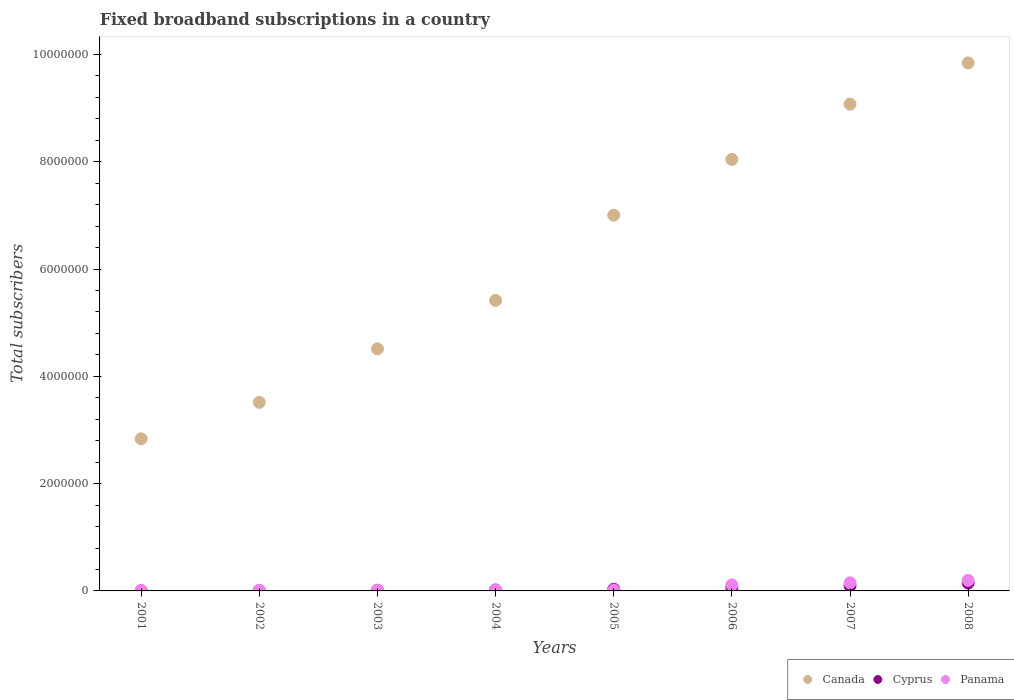How many different coloured dotlines are there?
Make the answer very short. 3. What is the number of broadband subscriptions in Canada in 2001?
Make the answer very short. 2.84e+06. Across all years, what is the maximum number of broadband subscriptions in Canada?
Your answer should be very brief. 9.84e+06. Across all years, what is the minimum number of broadband subscriptions in Panama?
Provide a succinct answer. 7771. In which year was the number of broadband subscriptions in Cyprus maximum?
Provide a short and direct response. 2008. In which year was the number of broadband subscriptions in Panama minimum?
Make the answer very short. 2001. What is the total number of broadband subscriptions in Cyprus in the graph?
Offer a terse response. 3.75e+05. What is the difference between the number of broadband subscriptions in Panama in 2001 and that in 2007?
Provide a short and direct response. -1.43e+05. What is the difference between the number of broadband subscriptions in Cyprus in 2005 and the number of broadband subscriptions in Panama in 2008?
Your answer should be very brief. -1.64e+05. What is the average number of broadband subscriptions in Canada per year?
Provide a succinct answer. 6.28e+06. In the year 2003, what is the difference between the number of broadband subscriptions in Panama and number of broadband subscriptions in Cyprus?
Provide a succinct answer. 5006. What is the ratio of the number of broadband subscriptions in Canada in 2005 to that in 2008?
Give a very brief answer. 0.71. What is the difference between the highest and the second highest number of broadband subscriptions in Canada?
Your response must be concise. 7.67e+05. What is the difference between the highest and the lowest number of broadband subscriptions in Cyprus?
Your answer should be compact. 1.45e+05. Is the sum of the number of broadband subscriptions in Cyprus in 2003 and 2004 greater than the maximum number of broadband subscriptions in Canada across all years?
Your response must be concise. No. How many years are there in the graph?
Your response must be concise. 8. Are the values on the major ticks of Y-axis written in scientific E-notation?
Your answer should be very brief. No. Does the graph contain any zero values?
Your answer should be very brief. No. Does the graph contain grids?
Your response must be concise. No. How many legend labels are there?
Offer a terse response. 3. How are the legend labels stacked?
Offer a terse response. Horizontal. What is the title of the graph?
Your answer should be very brief. Fixed broadband subscriptions in a country. Does "Samoa" appear as one of the legend labels in the graph?
Your answer should be compact. No. What is the label or title of the Y-axis?
Ensure brevity in your answer.  Total subscribers. What is the Total subscribers in Canada in 2001?
Provide a short and direct response. 2.84e+06. What is the Total subscribers in Cyprus in 2001?
Keep it short and to the point. 2500. What is the Total subscribers of Panama in 2001?
Ensure brevity in your answer.  7771. What is the Total subscribers of Canada in 2002?
Your response must be concise. 3.52e+06. What is the Total subscribers of Cyprus in 2002?
Your answer should be compact. 5879. What is the Total subscribers of Panama in 2002?
Your response must be concise. 1.22e+04. What is the Total subscribers in Canada in 2003?
Your answer should be very brief. 4.51e+06. What is the Total subscribers in Cyprus in 2003?
Offer a very short reply. 1.00e+04. What is the Total subscribers in Panama in 2003?
Provide a short and direct response. 1.50e+04. What is the Total subscribers of Canada in 2004?
Your response must be concise. 5.42e+06. What is the Total subscribers of Cyprus in 2004?
Your answer should be compact. 1.71e+04. What is the Total subscribers of Panama in 2004?
Provide a succinct answer. 1.67e+04. What is the Total subscribers in Canada in 2005?
Your answer should be very brief. 7.00e+06. What is the Total subscribers of Cyprus in 2005?
Offer a very short reply. 3.19e+04. What is the Total subscribers of Panama in 2005?
Ensure brevity in your answer.  1.76e+04. What is the Total subscribers in Canada in 2006?
Your answer should be very brief. 8.04e+06. What is the Total subscribers in Cyprus in 2006?
Provide a succinct answer. 6.31e+04. What is the Total subscribers in Panama in 2006?
Give a very brief answer. 1.13e+05. What is the Total subscribers of Canada in 2007?
Your response must be concise. 9.08e+06. What is the Total subscribers of Cyprus in 2007?
Make the answer very short. 9.76e+04. What is the Total subscribers of Panama in 2007?
Offer a terse response. 1.50e+05. What is the Total subscribers of Canada in 2008?
Your answer should be compact. 9.84e+06. What is the Total subscribers of Cyprus in 2008?
Offer a terse response. 1.47e+05. What is the Total subscribers of Panama in 2008?
Your answer should be very brief. 1.96e+05. Across all years, what is the maximum Total subscribers in Canada?
Provide a short and direct response. 9.84e+06. Across all years, what is the maximum Total subscribers in Cyprus?
Keep it short and to the point. 1.47e+05. Across all years, what is the maximum Total subscribers in Panama?
Ensure brevity in your answer.  1.96e+05. Across all years, what is the minimum Total subscribers in Canada?
Provide a short and direct response. 2.84e+06. Across all years, what is the minimum Total subscribers of Cyprus?
Provide a short and direct response. 2500. Across all years, what is the minimum Total subscribers in Panama?
Keep it short and to the point. 7771. What is the total Total subscribers in Canada in the graph?
Offer a terse response. 5.02e+07. What is the total Total subscribers in Cyprus in the graph?
Your response must be concise. 3.75e+05. What is the total Total subscribers of Panama in the graph?
Your response must be concise. 5.29e+05. What is the difference between the Total subscribers in Canada in 2001 and that in 2002?
Keep it short and to the point. -6.79e+05. What is the difference between the Total subscribers of Cyprus in 2001 and that in 2002?
Make the answer very short. -3379. What is the difference between the Total subscribers of Panama in 2001 and that in 2002?
Your answer should be very brief. -4464. What is the difference between the Total subscribers in Canada in 2001 and that in 2003?
Your answer should be compact. -1.68e+06. What is the difference between the Total subscribers in Cyprus in 2001 and that in 2003?
Your response must be concise. -7533. What is the difference between the Total subscribers of Panama in 2001 and that in 2003?
Make the answer very short. -7268. What is the difference between the Total subscribers in Canada in 2001 and that in 2004?
Keep it short and to the point. -2.58e+06. What is the difference between the Total subscribers of Cyprus in 2001 and that in 2004?
Provide a succinct answer. -1.46e+04. What is the difference between the Total subscribers in Panama in 2001 and that in 2004?
Keep it short and to the point. -8975. What is the difference between the Total subscribers of Canada in 2001 and that in 2005?
Make the answer very short. -4.17e+06. What is the difference between the Total subscribers of Cyprus in 2001 and that in 2005?
Provide a short and direct response. -2.94e+04. What is the difference between the Total subscribers in Panama in 2001 and that in 2005?
Provide a succinct answer. -9796. What is the difference between the Total subscribers in Canada in 2001 and that in 2006?
Provide a succinct answer. -5.21e+06. What is the difference between the Total subscribers of Cyprus in 2001 and that in 2006?
Offer a terse response. -6.06e+04. What is the difference between the Total subscribers of Panama in 2001 and that in 2006?
Keep it short and to the point. -1.05e+05. What is the difference between the Total subscribers in Canada in 2001 and that in 2007?
Give a very brief answer. -6.24e+06. What is the difference between the Total subscribers of Cyprus in 2001 and that in 2007?
Keep it short and to the point. -9.51e+04. What is the difference between the Total subscribers in Panama in 2001 and that in 2007?
Offer a very short reply. -1.43e+05. What is the difference between the Total subscribers in Canada in 2001 and that in 2008?
Your response must be concise. -7.01e+06. What is the difference between the Total subscribers of Cyprus in 2001 and that in 2008?
Make the answer very short. -1.45e+05. What is the difference between the Total subscribers in Panama in 2001 and that in 2008?
Provide a short and direct response. -1.88e+05. What is the difference between the Total subscribers of Canada in 2002 and that in 2003?
Ensure brevity in your answer.  -9.98e+05. What is the difference between the Total subscribers of Cyprus in 2002 and that in 2003?
Offer a very short reply. -4154. What is the difference between the Total subscribers in Panama in 2002 and that in 2003?
Offer a very short reply. -2804. What is the difference between the Total subscribers of Canada in 2002 and that in 2004?
Your answer should be very brief. -1.90e+06. What is the difference between the Total subscribers in Cyprus in 2002 and that in 2004?
Keep it short and to the point. -1.12e+04. What is the difference between the Total subscribers of Panama in 2002 and that in 2004?
Offer a terse response. -4511. What is the difference between the Total subscribers of Canada in 2002 and that in 2005?
Provide a succinct answer. -3.49e+06. What is the difference between the Total subscribers in Cyprus in 2002 and that in 2005?
Provide a short and direct response. -2.60e+04. What is the difference between the Total subscribers in Panama in 2002 and that in 2005?
Give a very brief answer. -5332. What is the difference between the Total subscribers of Canada in 2002 and that in 2006?
Your answer should be very brief. -4.53e+06. What is the difference between the Total subscribers in Cyprus in 2002 and that in 2006?
Offer a very short reply. -5.72e+04. What is the difference between the Total subscribers in Panama in 2002 and that in 2006?
Provide a short and direct response. -1.01e+05. What is the difference between the Total subscribers in Canada in 2002 and that in 2007?
Make the answer very short. -5.56e+06. What is the difference between the Total subscribers of Cyprus in 2002 and that in 2007?
Your response must be concise. -9.17e+04. What is the difference between the Total subscribers in Panama in 2002 and that in 2007?
Offer a very short reply. -1.38e+05. What is the difference between the Total subscribers in Canada in 2002 and that in 2008?
Offer a very short reply. -6.33e+06. What is the difference between the Total subscribers of Cyprus in 2002 and that in 2008?
Your answer should be very brief. -1.41e+05. What is the difference between the Total subscribers of Panama in 2002 and that in 2008?
Ensure brevity in your answer.  -1.84e+05. What is the difference between the Total subscribers of Canada in 2003 and that in 2004?
Keep it short and to the point. -9.03e+05. What is the difference between the Total subscribers in Cyprus in 2003 and that in 2004?
Your answer should be compact. -7037. What is the difference between the Total subscribers in Panama in 2003 and that in 2004?
Your response must be concise. -1707. What is the difference between the Total subscribers in Canada in 2003 and that in 2005?
Ensure brevity in your answer.  -2.49e+06. What is the difference between the Total subscribers of Cyprus in 2003 and that in 2005?
Your answer should be very brief. -2.18e+04. What is the difference between the Total subscribers of Panama in 2003 and that in 2005?
Your answer should be compact. -2528. What is the difference between the Total subscribers of Canada in 2003 and that in 2006?
Provide a succinct answer. -3.53e+06. What is the difference between the Total subscribers in Cyprus in 2003 and that in 2006?
Give a very brief answer. -5.31e+04. What is the difference between the Total subscribers in Panama in 2003 and that in 2006?
Ensure brevity in your answer.  -9.77e+04. What is the difference between the Total subscribers of Canada in 2003 and that in 2007?
Your response must be concise. -4.56e+06. What is the difference between the Total subscribers of Cyprus in 2003 and that in 2007?
Provide a succinct answer. -8.76e+04. What is the difference between the Total subscribers of Panama in 2003 and that in 2007?
Your answer should be compact. -1.35e+05. What is the difference between the Total subscribers of Canada in 2003 and that in 2008?
Keep it short and to the point. -5.33e+06. What is the difference between the Total subscribers in Cyprus in 2003 and that in 2008?
Make the answer very short. -1.37e+05. What is the difference between the Total subscribers in Panama in 2003 and that in 2008?
Your response must be concise. -1.81e+05. What is the difference between the Total subscribers in Canada in 2004 and that in 2005?
Ensure brevity in your answer.  -1.59e+06. What is the difference between the Total subscribers of Cyprus in 2004 and that in 2005?
Provide a succinct answer. -1.48e+04. What is the difference between the Total subscribers of Panama in 2004 and that in 2005?
Provide a succinct answer. -821. What is the difference between the Total subscribers in Canada in 2004 and that in 2006?
Give a very brief answer. -2.63e+06. What is the difference between the Total subscribers of Cyprus in 2004 and that in 2006?
Your response must be concise. -4.60e+04. What is the difference between the Total subscribers in Panama in 2004 and that in 2006?
Ensure brevity in your answer.  -9.60e+04. What is the difference between the Total subscribers of Canada in 2004 and that in 2007?
Your answer should be very brief. -3.66e+06. What is the difference between the Total subscribers of Cyprus in 2004 and that in 2007?
Provide a short and direct response. -8.05e+04. What is the difference between the Total subscribers of Panama in 2004 and that in 2007?
Give a very brief answer. -1.34e+05. What is the difference between the Total subscribers of Canada in 2004 and that in 2008?
Your answer should be compact. -4.43e+06. What is the difference between the Total subscribers of Cyprus in 2004 and that in 2008?
Make the answer very short. -1.30e+05. What is the difference between the Total subscribers of Panama in 2004 and that in 2008?
Your response must be concise. -1.79e+05. What is the difference between the Total subscribers of Canada in 2005 and that in 2006?
Make the answer very short. -1.04e+06. What is the difference between the Total subscribers in Cyprus in 2005 and that in 2006?
Provide a short and direct response. -3.12e+04. What is the difference between the Total subscribers of Panama in 2005 and that in 2006?
Offer a very short reply. -9.52e+04. What is the difference between the Total subscribers of Canada in 2005 and that in 2007?
Provide a short and direct response. -2.07e+06. What is the difference between the Total subscribers of Cyprus in 2005 and that in 2007?
Offer a very short reply. -6.58e+04. What is the difference between the Total subscribers in Panama in 2005 and that in 2007?
Ensure brevity in your answer.  -1.33e+05. What is the difference between the Total subscribers in Canada in 2005 and that in 2008?
Your answer should be compact. -2.84e+06. What is the difference between the Total subscribers in Cyprus in 2005 and that in 2008?
Provide a succinct answer. -1.15e+05. What is the difference between the Total subscribers of Panama in 2005 and that in 2008?
Give a very brief answer. -1.79e+05. What is the difference between the Total subscribers of Canada in 2006 and that in 2007?
Ensure brevity in your answer.  -1.03e+06. What is the difference between the Total subscribers in Cyprus in 2006 and that in 2007?
Provide a short and direct response. -3.45e+04. What is the difference between the Total subscribers in Panama in 2006 and that in 2007?
Keep it short and to the point. -3.75e+04. What is the difference between the Total subscribers in Canada in 2006 and that in 2008?
Keep it short and to the point. -1.80e+06. What is the difference between the Total subscribers of Cyprus in 2006 and that in 2008?
Keep it short and to the point. -8.42e+04. What is the difference between the Total subscribers in Panama in 2006 and that in 2008?
Give a very brief answer. -8.35e+04. What is the difference between the Total subscribers in Canada in 2007 and that in 2008?
Provide a succinct answer. -7.67e+05. What is the difference between the Total subscribers of Cyprus in 2007 and that in 2008?
Ensure brevity in your answer.  -4.97e+04. What is the difference between the Total subscribers of Panama in 2007 and that in 2008?
Give a very brief answer. -4.59e+04. What is the difference between the Total subscribers of Canada in 2001 and the Total subscribers of Cyprus in 2002?
Provide a short and direct response. 2.83e+06. What is the difference between the Total subscribers of Canada in 2001 and the Total subscribers of Panama in 2002?
Give a very brief answer. 2.82e+06. What is the difference between the Total subscribers in Cyprus in 2001 and the Total subscribers in Panama in 2002?
Provide a short and direct response. -9735. What is the difference between the Total subscribers of Canada in 2001 and the Total subscribers of Cyprus in 2003?
Offer a terse response. 2.83e+06. What is the difference between the Total subscribers in Canada in 2001 and the Total subscribers in Panama in 2003?
Offer a terse response. 2.82e+06. What is the difference between the Total subscribers in Cyprus in 2001 and the Total subscribers in Panama in 2003?
Keep it short and to the point. -1.25e+04. What is the difference between the Total subscribers of Canada in 2001 and the Total subscribers of Cyprus in 2004?
Ensure brevity in your answer.  2.82e+06. What is the difference between the Total subscribers in Canada in 2001 and the Total subscribers in Panama in 2004?
Ensure brevity in your answer.  2.82e+06. What is the difference between the Total subscribers in Cyprus in 2001 and the Total subscribers in Panama in 2004?
Provide a short and direct response. -1.42e+04. What is the difference between the Total subscribers of Canada in 2001 and the Total subscribers of Cyprus in 2005?
Offer a very short reply. 2.80e+06. What is the difference between the Total subscribers of Canada in 2001 and the Total subscribers of Panama in 2005?
Provide a succinct answer. 2.82e+06. What is the difference between the Total subscribers of Cyprus in 2001 and the Total subscribers of Panama in 2005?
Keep it short and to the point. -1.51e+04. What is the difference between the Total subscribers of Canada in 2001 and the Total subscribers of Cyprus in 2006?
Your answer should be compact. 2.77e+06. What is the difference between the Total subscribers in Canada in 2001 and the Total subscribers in Panama in 2006?
Ensure brevity in your answer.  2.72e+06. What is the difference between the Total subscribers of Cyprus in 2001 and the Total subscribers of Panama in 2006?
Your answer should be compact. -1.10e+05. What is the difference between the Total subscribers of Canada in 2001 and the Total subscribers of Cyprus in 2007?
Your response must be concise. 2.74e+06. What is the difference between the Total subscribers of Canada in 2001 and the Total subscribers of Panama in 2007?
Give a very brief answer. 2.69e+06. What is the difference between the Total subscribers of Cyprus in 2001 and the Total subscribers of Panama in 2007?
Offer a very short reply. -1.48e+05. What is the difference between the Total subscribers in Canada in 2001 and the Total subscribers in Cyprus in 2008?
Your answer should be very brief. 2.69e+06. What is the difference between the Total subscribers of Canada in 2001 and the Total subscribers of Panama in 2008?
Your response must be concise. 2.64e+06. What is the difference between the Total subscribers of Cyprus in 2001 and the Total subscribers of Panama in 2008?
Provide a short and direct response. -1.94e+05. What is the difference between the Total subscribers in Canada in 2002 and the Total subscribers in Cyprus in 2003?
Your answer should be compact. 3.50e+06. What is the difference between the Total subscribers of Canada in 2002 and the Total subscribers of Panama in 2003?
Offer a very short reply. 3.50e+06. What is the difference between the Total subscribers of Cyprus in 2002 and the Total subscribers of Panama in 2003?
Your answer should be compact. -9160. What is the difference between the Total subscribers of Canada in 2002 and the Total subscribers of Cyprus in 2004?
Provide a succinct answer. 3.50e+06. What is the difference between the Total subscribers in Canada in 2002 and the Total subscribers in Panama in 2004?
Your answer should be compact. 3.50e+06. What is the difference between the Total subscribers in Cyprus in 2002 and the Total subscribers in Panama in 2004?
Provide a short and direct response. -1.09e+04. What is the difference between the Total subscribers in Canada in 2002 and the Total subscribers in Cyprus in 2005?
Make the answer very short. 3.48e+06. What is the difference between the Total subscribers of Canada in 2002 and the Total subscribers of Panama in 2005?
Provide a short and direct response. 3.50e+06. What is the difference between the Total subscribers in Cyprus in 2002 and the Total subscribers in Panama in 2005?
Give a very brief answer. -1.17e+04. What is the difference between the Total subscribers in Canada in 2002 and the Total subscribers in Cyprus in 2006?
Provide a succinct answer. 3.45e+06. What is the difference between the Total subscribers of Canada in 2002 and the Total subscribers of Panama in 2006?
Your answer should be very brief. 3.40e+06. What is the difference between the Total subscribers of Cyprus in 2002 and the Total subscribers of Panama in 2006?
Your response must be concise. -1.07e+05. What is the difference between the Total subscribers of Canada in 2002 and the Total subscribers of Cyprus in 2007?
Provide a short and direct response. 3.42e+06. What is the difference between the Total subscribers in Canada in 2002 and the Total subscribers in Panama in 2007?
Provide a succinct answer. 3.36e+06. What is the difference between the Total subscribers in Cyprus in 2002 and the Total subscribers in Panama in 2007?
Ensure brevity in your answer.  -1.44e+05. What is the difference between the Total subscribers in Canada in 2002 and the Total subscribers in Cyprus in 2008?
Provide a short and direct response. 3.37e+06. What is the difference between the Total subscribers of Canada in 2002 and the Total subscribers of Panama in 2008?
Provide a succinct answer. 3.32e+06. What is the difference between the Total subscribers in Cyprus in 2002 and the Total subscribers in Panama in 2008?
Provide a short and direct response. -1.90e+05. What is the difference between the Total subscribers in Canada in 2003 and the Total subscribers in Cyprus in 2004?
Your answer should be compact. 4.50e+06. What is the difference between the Total subscribers of Canada in 2003 and the Total subscribers of Panama in 2004?
Your answer should be compact. 4.50e+06. What is the difference between the Total subscribers in Cyprus in 2003 and the Total subscribers in Panama in 2004?
Provide a succinct answer. -6713. What is the difference between the Total subscribers in Canada in 2003 and the Total subscribers in Cyprus in 2005?
Make the answer very short. 4.48e+06. What is the difference between the Total subscribers of Canada in 2003 and the Total subscribers of Panama in 2005?
Offer a very short reply. 4.50e+06. What is the difference between the Total subscribers of Cyprus in 2003 and the Total subscribers of Panama in 2005?
Your response must be concise. -7534. What is the difference between the Total subscribers of Canada in 2003 and the Total subscribers of Cyprus in 2006?
Offer a very short reply. 4.45e+06. What is the difference between the Total subscribers of Canada in 2003 and the Total subscribers of Panama in 2006?
Provide a short and direct response. 4.40e+06. What is the difference between the Total subscribers of Cyprus in 2003 and the Total subscribers of Panama in 2006?
Give a very brief answer. -1.03e+05. What is the difference between the Total subscribers of Canada in 2003 and the Total subscribers of Cyprus in 2007?
Keep it short and to the point. 4.42e+06. What is the difference between the Total subscribers of Canada in 2003 and the Total subscribers of Panama in 2007?
Offer a terse response. 4.36e+06. What is the difference between the Total subscribers in Cyprus in 2003 and the Total subscribers in Panama in 2007?
Your answer should be very brief. -1.40e+05. What is the difference between the Total subscribers of Canada in 2003 and the Total subscribers of Cyprus in 2008?
Keep it short and to the point. 4.37e+06. What is the difference between the Total subscribers in Canada in 2003 and the Total subscribers in Panama in 2008?
Provide a succinct answer. 4.32e+06. What is the difference between the Total subscribers of Cyprus in 2003 and the Total subscribers of Panama in 2008?
Offer a terse response. -1.86e+05. What is the difference between the Total subscribers in Canada in 2004 and the Total subscribers in Cyprus in 2005?
Make the answer very short. 5.38e+06. What is the difference between the Total subscribers of Canada in 2004 and the Total subscribers of Panama in 2005?
Make the answer very short. 5.40e+06. What is the difference between the Total subscribers in Cyprus in 2004 and the Total subscribers in Panama in 2005?
Give a very brief answer. -497. What is the difference between the Total subscribers in Canada in 2004 and the Total subscribers in Cyprus in 2006?
Offer a very short reply. 5.35e+06. What is the difference between the Total subscribers in Canada in 2004 and the Total subscribers in Panama in 2006?
Your answer should be compact. 5.30e+06. What is the difference between the Total subscribers of Cyprus in 2004 and the Total subscribers of Panama in 2006?
Keep it short and to the point. -9.57e+04. What is the difference between the Total subscribers of Canada in 2004 and the Total subscribers of Cyprus in 2007?
Offer a very short reply. 5.32e+06. What is the difference between the Total subscribers in Canada in 2004 and the Total subscribers in Panama in 2007?
Provide a succinct answer. 5.27e+06. What is the difference between the Total subscribers in Cyprus in 2004 and the Total subscribers in Panama in 2007?
Give a very brief answer. -1.33e+05. What is the difference between the Total subscribers of Canada in 2004 and the Total subscribers of Cyprus in 2008?
Make the answer very short. 5.27e+06. What is the difference between the Total subscribers of Canada in 2004 and the Total subscribers of Panama in 2008?
Keep it short and to the point. 5.22e+06. What is the difference between the Total subscribers in Cyprus in 2004 and the Total subscribers in Panama in 2008?
Offer a terse response. -1.79e+05. What is the difference between the Total subscribers of Canada in 2005 and the Total subscribers of Cyprus in 2006?
Provide a short and direct response. 6.94e+06. What is the difference between the Total subscribers in Canada in 2005 and the Total subscribers in Panama in 2006?
Provide a succinct answer. 6.89e+06. What is the difference between the Total subscribers in Cyprus in 2005 and the Total subscribers in Panama in 2006?
Provide a short and direct response. -8.09e+04. What is the difference between the Total subscribers of Canada in 2005 and the Total subscribers of Cyprus in 2007?
Your answer should be very brief. 6.91e+06. What is the difference between the Total subscribers in Canada in 2005 and the Total subscribers in Panama in 2007?
Your answer should be very brief. 6.85e+06. What is the difference between the Total subscribers in Cyprus in 2005 and the Total subscribers in Panama in 2007?
Offer a terse response. -1.18e+05. What is the difference between the Total subscribers of Canada in 2005 and the Total subscribers of Cyprus in 2008?
Offer a very short reply. 6.86e+06. What is the difference between the Total subscribers in Canada in 2005 and the Total subscribers in Panama in 2008?
Your response must be concise. 6.81e+06. What is the difference between the Total subscribers of Cyprus in 2005 and the Total subscribers of Panama in 2008?
Provide a succinct answer. -1.64e+05. What is the difference between the Total subscribers in Canada in 2006 and the Total subscribers in Cyprus in 2007?
Your answer should be very brief. 7.95e+06. What is the difference between the Total subscribers in Canada in 2006 and the Total subscribers in Panama in 2007?
Offer a terse response. 7.89e+06. What is the difference between the Total subscribers of Cyprus in 2006 and the Total subscribers of Panama in 2007?
Make the answer very short. -8.72e+04. What is the difference between the Total subscribers in Canada in 2006 and the Total subscribers in Cyprus in 2008?
Offer a very short reply. 7.90e+06. What is the difference between the Total subscribers in Canada in 2006 and the Total subscribers in Panama in 2008?
Provide a succinct answer. 7.85e+06. What is the difference between the Total subscribers of Cyprus in 2006 and the Total subscribers of Panama in 2008?
Provide a short and direct response. -1.33e+05. What is the difference between the Total subscribers of Canada in 2007 and the Total subscribers of Cyprus in 2008?
Offer a terse response. 8.93e+06. What is the difference between the Total subscribers in Canada in 2007 and the Total subscribers in Panama in 2008?
Your answer should be compact. 8.88e+06. What is the difference between the Total subscribers of Cyprus in 2007 and the Total subscribers of Panama in 2008?
Your response must be concise. -9.86e+04. What is the average Total subscribers of Canada per year?
Make the answer very short. 6.28e+06. What is the average Total subscribers in Cyprus per year?
Offer a terse response. 4.69e+04. What is the average Total subscribers of Panama per year?
Provide a succinct answer. 6.61e+04. In the year 2001, what is the difference between the Total subscribers in Canada and Total subscribers in Cyprus?
Give a very brief answer. 2.83e+06. In the year 2001, what is the difference between the Total subscribers of Canada and Total subscribers of Panama?
Offer a very short reply. 2.83e+06. In the year 2001, what is the difference between the Total subscribers of Cyprus and Total subscribers of Panama?
Keep it short and to the point. -5271. In the year 2002, what is the difference between the Total subscribers in Canada and Total subscribers in Cyprus?
Make the answer very short. 3.51e+06. In the year 2002, what is the difference between the Total subscribers of Canada and Total subscribers of Panama?
Make the answer very short. 3.50e+06. In the year 2002, what is the difference between the Total subscribers of Cyprus and Total subscribers of Panama?
Offer a terse response. -6356. In the year 2003, what is the difference between the Total subscribers in Canada and Total subscribers in Cyprus?
Provide a short and direct response. 4.50e+06. In the year 2003, what is the difference between the Total subscribers of Canada and Total subscribers of Panama?
Offer a terse response. 4.50e+06. In the year 2003, what is the difference between the Total subscribers in Cyprus and Total subscribers in Panama?
Provide a short and direct response. -5006. In the year 2004, what is the difference between the Total subscribers of Canada and Total subscribers of Cyprus?
Offer a terse response. 5.40e+06. In the year 2004, what is the difference between the Total subscribers in Canada and Total subscribers in Panama?
Offer a terse response. 5.40e+06. In the year 2004, what is the difference between the Total subscribers of Cyprus and Total subscribers of Panama?
Ensure brevity in your answer.  324. In the year 2005, what is the difference between the Total subscribers of Canada and Total subscribers of Cyprus?
Provide a succinct answer. 6.97e+06. In the year 2005, what is the difference between the Total subscribers of Canada and Total subscribers of Panama?
Ensure brevity in your answer.  6.99e+06. In the year 2005, what is the difference between the Total subscribers of Cyprus and Total subscribers of Panama?
Make the answer very short. 1.43e+04. In the year 2006, what is the difference between the Total subscribers of Canada and Total subscribers of Cyprus?
Your answer should be compact. 7.98e+06. In the year 2006, what is the difference between the Total subscribers in Canada and Total subscribers in Panama?
Make the answer very short. 7.93e+06. In the year 2006, what is the difference between the Total subscribers in Cyprus and Total subscribers in Panama?
Give a very brief answer. -4.97e+04. In the year 2007, what is the difference between the Total subscribers in Canada and Total subscribers in Cyprus?
Offer a very short reply. 8.98e+06. In the year 2007, what is the difference between the Total subscribers in Canada and Total subscribers in Panama?
Keep it short and to the point. 8.93e+06. In the year 2007, what is the difference between the Total subscribers of Cyprus and Total subscribers of Panama?
Your response must be concise. -5.27e+04. In the year 2008, what is the difference between the Total subscribers of Canada and Total subscribers of Cyprus?
Offer a terse response. 9.70e+06. In the year 2008, what is the difference between the Total subscribers of Canada and Total subscribers of Panama?
Your answer should be compact. 9.65e+06. In the year 2008, what is the difference between the Total subscribers in Cyprus and Total subscribers in Panama?
Your answer should be compact. -4.89e+04. What is the ratio of the Total subscribers of Canada in 2001 to that in 2002?
Ensure brevity in your answer.  0.81. What is the ratio of the Total subscribers of Cyprus in 2001 to that in 2002?
Provide a succinct answer. 0.43. What is the ratio of the Total subscribers of Panama in 2001 to that in 2002?
Your answer should be very brief. 0.64. What is the ratio of the Total subscribers in Canada in 2001 to that in 2003?
Provide a succinct answer. 0.63. What is the ratio of the Total subscribers of Cyprus in 2001 to that in 2003?
Provide a short and direct response. 0.25. What is the ratio of the Total subscribers of Panama in 2001 to that in 2003?
Your answer should be compact. 0.52. What is the ratio of the Total subscribers in Canada in 2001 to that in 2004?
Your response must be concise. 0.52. What is the ratio of the Total subscribers of Cyprus in 2001 to that in 2004?
Your response must be concise. 0.15. What is the ratio of the Total subscribers of Panama in 2001 to that in 2004?
Ensure brevity in your answer.  0.46. What is the ratio of the Total subscribers in Canada in 2001 to that in 2005?
Offer a very short reply. 0.4. What is the ratio of the Total subscribers of Cyprus in 2001 to that in 2005?
Your answer should be very brief. 0.08. What is the ratio of the Total subscribers in Panama in 2001 to that in 2005?
Ensure brevity in your answer.  0.44. What is the ratio of the Total subscribers in Canada in 2001 to that in 2006?
Your response must be concise. 0.35. What is the ratio of the Total subscribers in Cyprus in 2001 to that in 2006?
Provide a short and direct response. 0.04. What is the ratio of the Total subscribers of Panama in 2001 to that in 2006?
Make the answer very short. 0.07. What is the ratio of the Total subscribers of Canada in 2001 to that in 2007?
Provide a short and direct response. 0.31. What is the ratio of the Total subscribers in Cyprus in 2001 to that in 2007?
Keep it short and to the point. 0.03. What is the ratio of the Total subscribers of Panama in 2001 to that in 2007?
Provide a succinct answer. 0.05. What is the ratio of the Total subscribers in Canada in 2001 to that in 2008?
Offer a very short reply. 0.29. What is the ratio of the Total subscribers of Cyprus in 2001 to that in 2008?
Offer a terse response. 0.02. What is the ratio of the Total subscribers of Panama in 2001 to that in 2008?
Your answer should be compact. 0.04. What is the ratio of the Total subscribers of Canada in 2002 to that in 2003?
Offer a very short reply. 0.78. What is the ratio of the Total subscribers of Cyprus in 2002 to that in 2003?
Your answer should be very brief. 0.59. What is the ratio of the Total subscribers in Panama in 2002 to that in 2003?
Your answer should be compact. 0.81. What is the ratio of the Total subscribers in Canada in 2002 to that in 2004?
Offer a terse response. 0.65. What is the ratio of the Total subscribers of Cyprus in 2002 to that in 2004?
Keep it short and to the point. 0.34. What is the ratio of the Total subscribers of Panama in 2002 to that in 2004?
Give a very brief answer. 0.73. What is the ratio of the Total subscribers of Canada in 2002 to that in 2005?
Your answer should be compact. 0.5. What is the ratio of the Total subscribers in Cyprus in 2002 to that in 2005?
Provide a succinct answer. 0.18. What is the ratio of the Total subscribers of Panama in 2002 to that in 2005?
Your answer should be very brief. 0.7. What is the ratio of the Total subscribers of Canada in 2002 to that in 2006?
Ensure brevity in your answer.  0.44. What is the ratio of the Total subscribers in Cyprus in 2002 to that in 2006?
Your answer should be compact. 0.09. What is the ratio of the Total subscribers in Panama in 2002 to that in 2006?
Your response must be concise. 0.11. What is the ratio of the Total subscribers in Canada in 2002 to that in 2007?
Your response must be concise. 0.39. What is the ratio of the Total subscribers in Cyprus in 2002 to that in 2007?
Ensure brevity in your answer.  0.06. What is the ratio of the Total subscribers in Panama in 2002 to that in 2007?
Offer a very short reply. 0.08. What is the ratio of the Total subscribers in Canada in 2002 to that in 2008?
Make the answer very short. 0.36. What is the ratio of the Total subscribers of Cyprus in 2002 to that in 2008?
Your answer should be very brief. 0.04. What is the ratio of the Total subscribers of Panama in 2002 to that in 2008?
Your answer should be compact. 0.06. What is the ratio of the Total subscribers in Canada in 2003 to that in 2004?
Provide a short and direct response. 0.83. What is the ratio of the Total subscribers in Cyprus in 2003 to that in 2004?
Your response must be concise. 0.59. What is the ratio of the Total subscribers of Panama in 2003 to that in 2004?
Provide a succinct answer. 0.9. What is the ratio of the Total subscribers of Canada in 2003 to that in 2005?
Your answer should be very brief. 0.64. What is the ratio of the Total subscribers of Cyprus in 2003 to that in 2005?
Your response must be concise. 0.31. What is the ratio of the Total subscribers in Panama in 2003 to that in 2005?
Offer a terse response. 0.86. What is the ratio of the Total subscribers in Canada in 2003 to that in 2006?
Offer a terse response. 0.56. What is the ratio of the Total subscribers of Cyprus in 2003 to that in 2006?
Your answer should be compact. 0.16. What is the ratio of the Total subscribers in Panama in 2003 to that in 2006?
Your answer should be very brief. 0.13. What is the ratio of the Total subscribers of Canada in 2003 to that in 2007?
Your response must be concise. 0.5. What is the ratio of the Total subscribers of Cyprus in 2003 to that in 2007?
Your answer should be very brief. 0.1. What is the ratio of the Total subscribers in Panama in 2003 to that in 2007?
Your answer should be very brief. 0.1. What is the ratio of the Total subscribers in Canada in 2003 to that in 2008?
Your response must be concise. 0.46. What is the ratio of the Total subscribers in Cyprus in 2003 to that in 2008?
Your answer should be very brief. 0.07. What is the ratio of the Total subscribers in Panama in 2003 to that in 2008?
Make the answer very short. 0.08. What is the ratio of the Total subscribers of Canada in 2004 to that in 2005?
Give a very brief answer. 0.77. What is the ratio of the Total subscribers in Cyprus in 2004 to that in 2005?
Your answer should be compact. 0.54. What is the ratio of the Total subscribers in Panama in 2004 to that in 2005?
Offer a terse response. 0.95. What is the ratio of the Total subscribers in Canada in 2004 to that in 2006?
Offer a terse response. 0.67. What is the ratio of the Total subscribers of Cyprus in 2004 to that in 2006?
Provide a succinct answer. 0.27. What is the ratio of the Total subscribers of Panama in 2004 to that in 2006?
Give a very brief answer. 0.15. What is the ratio of the Total subscribers in Canada in 2004 to that in 2007?
Keep it short and to the point. 0.6. What is the ratio of the Total subscribers in Cyprus in 2004 to that in 2007?
Make the answer very short. 0.17. What is the ratio of the Total subscribers in Panama in 2004 to that in 2007?
Your answer should be very brief. 0.11. What is the ratio of the Total subscribers of Canada in 2004 to that in 2008?
Offer a terse response. 0.55. What is the ratio of the Total subscribers in Cyprus in 2004 to that in 2008?
Make the answer very short. 0.12. What is the ratio of the Total subscribers of Panama in 2004 to that in 2008?
Your answer should be very brief. 0.09. What is the ratio of the Total subscribers in Canada in 2005 to that in 2006?
Ensure brevity in your answer.  0.87. What is the ratio of the Total subscribers of Cyprus in 2005 to that in 2006?
Your answer should be compact. 0.51. What is the ratio of the Total subscribers of Panama in 2005 to that in 2006?
Provide a short and direct response. 0.16. What is the ratio of the Total subscribers of Canada in 2005 to that in 2007?
Offer a terse response. 0.77. What is the ratio of the Total subscribers in Cyprus in 2005 to that in 2007?
Your answer should be very brief. 0.33. What is the ratio of the Total subscribers in Panama in 2005 to that in 2007?
Give a very brief answer. 0.12. What is the ratio of the Total subscribers of Canada in 2005 to that in 2008?
Make the answer very short. 0.71. What is the ratio of the Total subscribers in Cyprus in 2005 to that in 2008?
Ensure brevity in your answer.  0.22. What is the ratio of the Total subscribers of Panama in 2005 to that in 2008?
Provide a short and direct response. 0.09. What is the ratio of the Total subscribers of Canada in 2006 to that in 2007?
Ensure brevity in your answer.  0.89. What is the ratio of the Total subscribers in Cyprus in 2006 to that in 2007?
Ensure brevity in your answer.  0.65. What is the ratio of the Total subscribers in Panama in 2006 to that in 2007?
Offer a very short reply. 0.75. What is the ratio of the Total subscribers of Canada in 2006 to that in 2008?
Offer a very short reply. 0.82. What is the ratio of the Total subscribers of Cyprus in 2006 to that in 2008?
Provide a short and direct response. 0.43. What is the ratio of the Total subscribers in Panama in 2006 to that in 2008?
Keep it short and to the point. 0.57. What is the ratio of the Total subscribers of Canada in 2007 to that in 2008?
Give a very brief answer. 0.92. What is the ratio of the Total subscribers of Cyprus in 2007 to that in 2008?
Make the answer very short. 0.66. What is the ratio of the Total subscribers of Panama in 2007 to that in 2008?
Your answer should be compact. 0.77. What is the difference between the highest and the second highest Total subscribers of Canada?
Give a very brief answer. 7.67e+05. What is the difference between the highest and the second highest Total subscribers of Cyprus?
Offer a terse response. 4.97e+04. What is the difference between the highest and the second highest Total subscribers of Panama?
Make the answer very short. 4.59e+04. What is the difference between the highest and the lowest Total subscribers in Canada?
Your answer should be compact. 7.01e+06. What is the difference between the highest and the lowest Total subscribers of Cyprus?
Provide a short and direct response. 1.45e+05. What is the difference between the highest and the lowest Total subscribers in Panama?
Your answer should be very brief. 1.88e+05. 